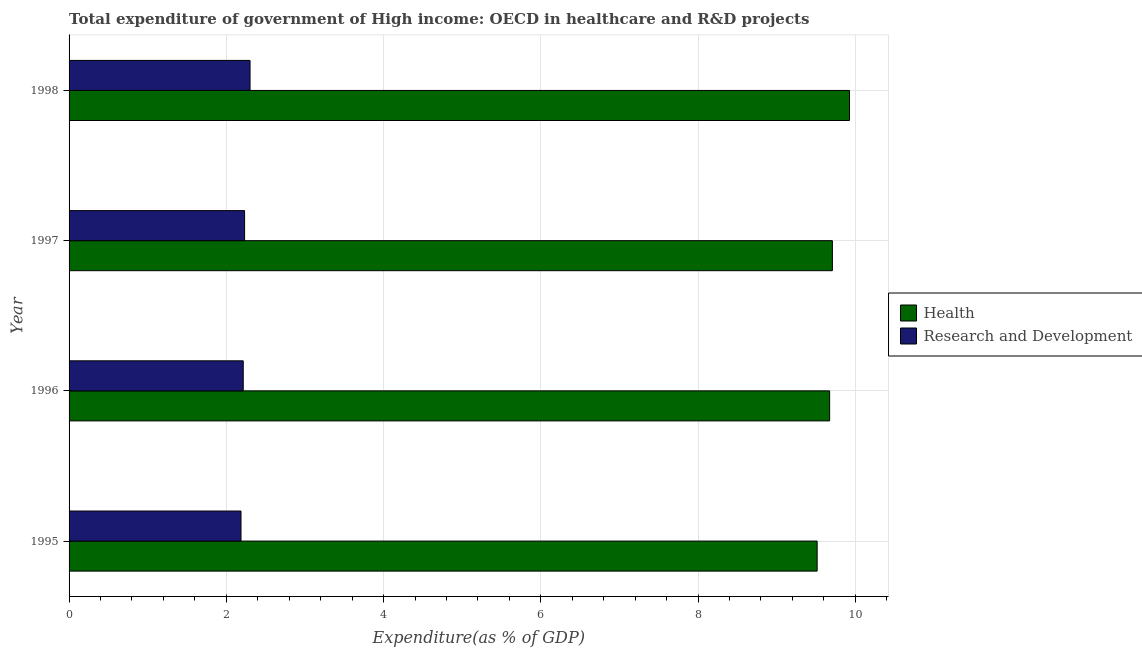Are the number of bars on each tick of the Y-axis equal?
Provide a short and direct response. Yes. What is the expenditure in r&d in 1995?
Ensure brevity in your answer.  2.19. Across all years, what is the maximum expenditure in r&d?
Your answer should be very brief. 2.3. Across all years, what is the minimum expenditure in r&d?
Make the answer very short. 2.19. What is the total expenditure in r&d in the graph?
Offer a very short reply. 8.94. What is the difference between the expenditure in r&d in 1995 and that in 1996?
Provide a short and direct response. -0.03. What is the difference between the expenditure in r&d in 1995 and the expenditure in healthcare in 1996?
Your answer should be very brief. -7.49. What is the average expenditure in r&d per year?
Make the answer very short. 2.23. In the year 1996, what is the difference between the expenditure in healthcare and expenditure in r&d?
Provide a short and direct response. 7.46. In how many years, is the expenditure in healthcare greater than 3.6 %?
Your response must be concise. 4. Is the difference between the expenditure in r&d in 1997 and 1998 greater than the difference between the expenditure in healthcare in 1997 and 1998?
Your answer should be very brief. Yes. What is the difference between the highest and the second highest expenditure in healthcare?
Keep it short and to the point. 0.22. What is the difference between the highest and the lowest expenditure in r&d?
Make the answer very short. 0.12. In how many years, is the expenditure in healthcare greater than the average expenditure in healthcare taken over all years?
Give a very brief answer. 2. What does the 1st bar from the top in 1995 represents?
Your answer should be very brief. Research and Development. What does the 1st bar from the bottom in 1997 represents?
Provide a short and direct response. Health. How many years are there in the graph?
Make the answer very short. 4. What is the difference between two consecutive major ticks on the X-axis?
Offer a very short reply. 2. How are the legend labels stacked?
Offer a terse response. Vertical. What is the title of the graph?
Ensure brevity in your answer.  Total expenditure of government of High income: OECD in healthcare and R&D projects. What is the label or title of the X-axis?
Keep it short and to the point. Expenditure(as % of GDP). What is the Expenditure(as % of GDP) of Health in 1995?
Ensure brevity in your answer.  9.51. What is the Expenditure(as % of GDP) of Research and Development in 1995?
Ensure brevity in your answer.  2.19. What is the Expenditure(as % of GDP) of Health in 1996?
Offer a very short reply. 9.67. What is the Expenditure(as % of GDP) in Research and Development in 1996?
Ensure brevity in your answer.  2.22. What is the Expenditure(as % of GDP) of Health in 1997?
Keep it short and to the point. 9.71. What is the Expenditure(as % of GDP) in Research and Development in 1997?
Give a very brief answer. 2.23. What is the Expenditure(as % of GDP) in Health in 1998?
Offer a very short reply. 9.93. What is the Expenditure(as % of GDP) of Research and Development in 1998?
Ensure brevity in your answer.  2.3. Across all years, what is the maximum Expenditure(as % of GDP) of Health?
Offer a terse response. 9.93. Across all years, what is the maximum Expenditure(as % of GDP) in Research and Development?
Make the answer very short. 2.3. Across all years, what is the minimum Expenditure(as % of GDP) in Health?
Your answer should be compact. 9.51. Across all years, what is the minimum Expenditure(as % of GDP) in Research and Development?
Keep it short and to the point. 2.19. What is the total Expenditure(as % of GDP) in Health in the graph?
Your response must be concise. 38.82. What is the total Expenditure(as % of GDP) in Research and Development in the graph?
Offer a very short reply. 8.94. What is the difference between the Expenditure(as % of GDP) of Health in 1995 and that in 1996?
Provide a short and direct response. -0.16. What is the difference between the Expenditure(as % of GDP) in Research and Development in 1995 and that in 1996?
Your answer should be very brief. -0.03. What is the difference between the Expenditure(as % of GDP) in Health in 1995 and that in 1997?
Your response must be concise. -0.19. What is the difference between the Expenditure(as % of GDP) in Research and Development in 1995 and that in 1997?
Offer a very short reply. -0.05. What is the difference between the Expenditure(as % of GDP) of Health in 1995 and that in 1998?
Your answer should be compact. -0.41. What is the difference between the Expenditure(as % of GDP) in Research and Development in 1995 and that in 1998?
Offer a terse response. -0.12. What is the difference between the Expenditure(as % of GDP) of Health in 1996 and that in 1997?
Keep it short and to the point. -0.03. What is the difference between the Expenditure(as % of GDP) of Research and Development in 1996 and that in 1997?
Give a very brief answer. -0.02. What is the difference between the Expenditure(as % of GDP) in Health in 1996 and that in 1998?
Ensure brevity in your answer.  -0.25. What is the difference between the Expenditure(as % of GDP) in Research and Development in 1996 and that in 1998?
Your answer should be compact. -0.09. What is the difference between the Expenditure(as % of GDP) of Health in 1997 and that in 1998?
Offer a terse response. -0.22. What is the difference between the Expenditure(as % of GDP) in Research and Development in 1997 and that in 1998?
Provide a succinct answer. -0.07. What is the difference between the Expenditure(as % of GDP) of Health in 1995 and the Expenditure(as % of GDP) of Research and Development in 1996?
Offer a terse response. 7.3. What is the difference between the Expenditure(as % of GDP) of Health in 1995 and the Expenditure(as % of GDP) of Research and Development in 1997?
Provide a succinct answer. 7.28. What is the difference between the Expenditure(as % of GDP) in Health in 1995 and the Expenditure(as % of GDP) in Research and Development in 1998?
Your response must be concise. 7.21. What is the difference between the Expenditure(as % of GDP) of Health in 1996 and the Expenditure(as % of GDP) of Research and Development in 1997?
Offer a very short reply. 7.44. What is the difference between the Expenditure(as % of GDP) in Health in 1996 and the Expenditure(as % of GDP) in Research and Development in 1998?
Keep it short and to the point. 7.37. What is the difference between the Expenditure(as % of GDP) of Health in 1997 and the Expenditure(as % of GDP) of Research and Development in 1998?
Provide a succinct answer. 7.41. What is the average Expenditure(as % of GDP) of Health per year?
Provide a succinct answer. 9.71. What is the average Expenditure(as % of GDP) of Research and Development per year?
Make the answer very short. 2.23. In the year 1995, what is the difference between the Expenditure(as % of GDP) in Health and Expenditure(as % of GDP) in Research and Development?
Provide a short and direct response. 7.33. In the year 1996, what is the difference between the Expenditure(as % of GDP) in Health and Expenditure(as % of GDP) in Research and Development?
Give a very brief answer. 7.46. In the year 1997, what is the difference between the Expenditure(as % of GDP) in Health and Expenditure(as % of GDP) in Research and Development?
Ensure brevity in your answer.  7.48. In the year 1998, what is the difference between the Expenditure(as % of GDP) of Health and Expenditure(as % of GDP) of Research and Development?
Make the answer very short. 7.62. What is the ratio of the Expenditure(as % of GDP) in Health in 1995 to that in 1996?
Your answer should be very brief. 0.98. What is the ratio of the Expenditure(as % of GDP) of Research and Development in 1995 to that in 1996?
Your answer should be very brief. 0.99. What is the ratio of the Expenditure(as % of GDP) in Research and Development in 1995 to that in 1997?
Offer a very short reply. 0.98. What is the ratio of the Expenditure(as % of GDP) in Health in 1995 to that in 1998?
Provide a short and direct response. 0.96. What is the ratio of the Expenditure(as % of GDP) in Health in 1996 to that in 1998?
Ensure brevity in your answer.  0.97. What is the ratio of the Expenditure(as % of GDP) of Research and Development in 1996 to that in 1998?
Make the answer very short. 0.96. What is the ratio of the Expenditure(as % of GDP) in Health in 1997 to that in 1998?
Ensure brevity in your answer.  0.98. What is the ratio of the Expenditure(as % of GDP) in Research and Development in 1997 to that in 1998?
Keep it short and to the point. 0.97. What is the difference between the highest and the second highest Expenditure(as % of GDP) of Health?
Make the answer very short. 0.22. What is the difference between the highest and the second highest Expenditure(as % of GDP) of Research and Development?
Keep it short and to the point. 0.07. What is the difference between the highest and the lowest Expenditure(as % of GDP) in Health?
Keep it short and to the point. 0.41. What is the difference between the highest and the lowest Expenditure(as % of GDP) of Research and Development?
Provide a succinct answer. 0.12. 